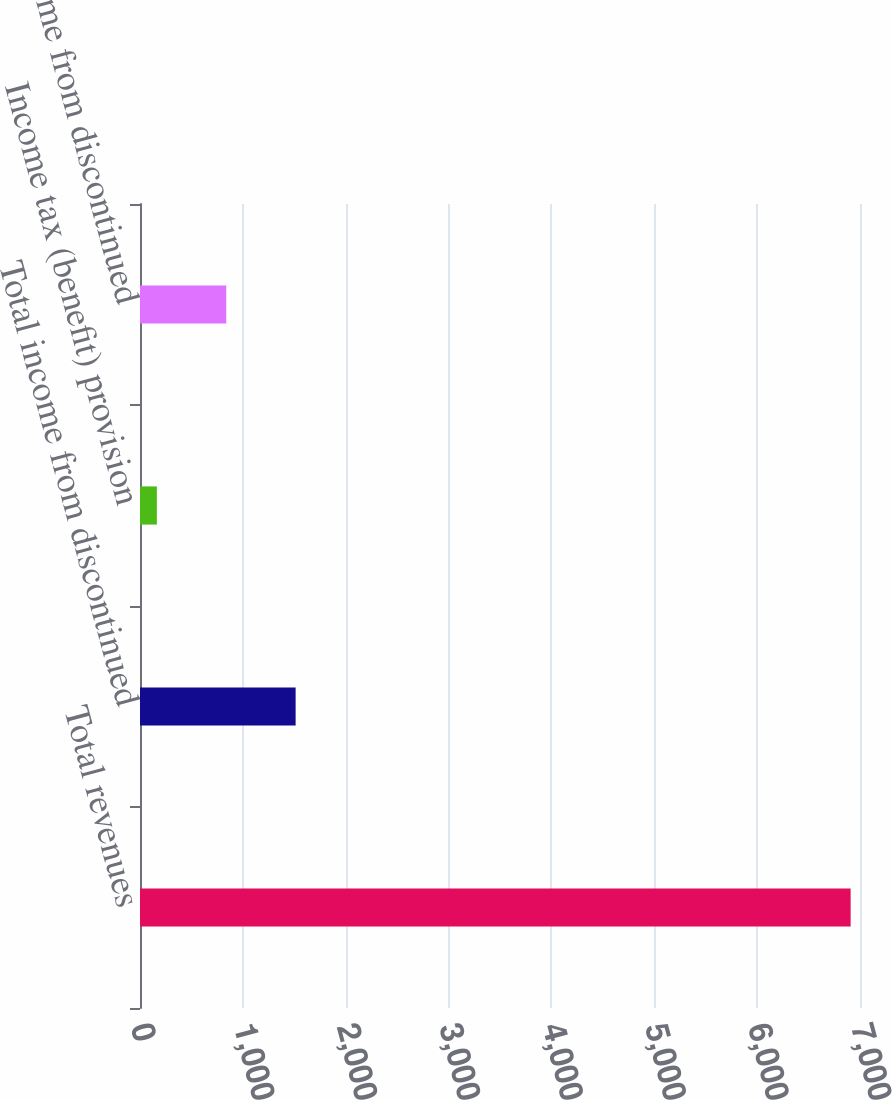<chart> <loc_0><loc_0><loc_500><loc_500><bar_chart><fcel>Total revenues<fcel>Total income from discontinued<fcel>Income tax (benefit) provision<fcel>Income from discontinued<nl><fcel>6909<fcel>1513<fcel>164<fcel>838.5<nl></chart> 